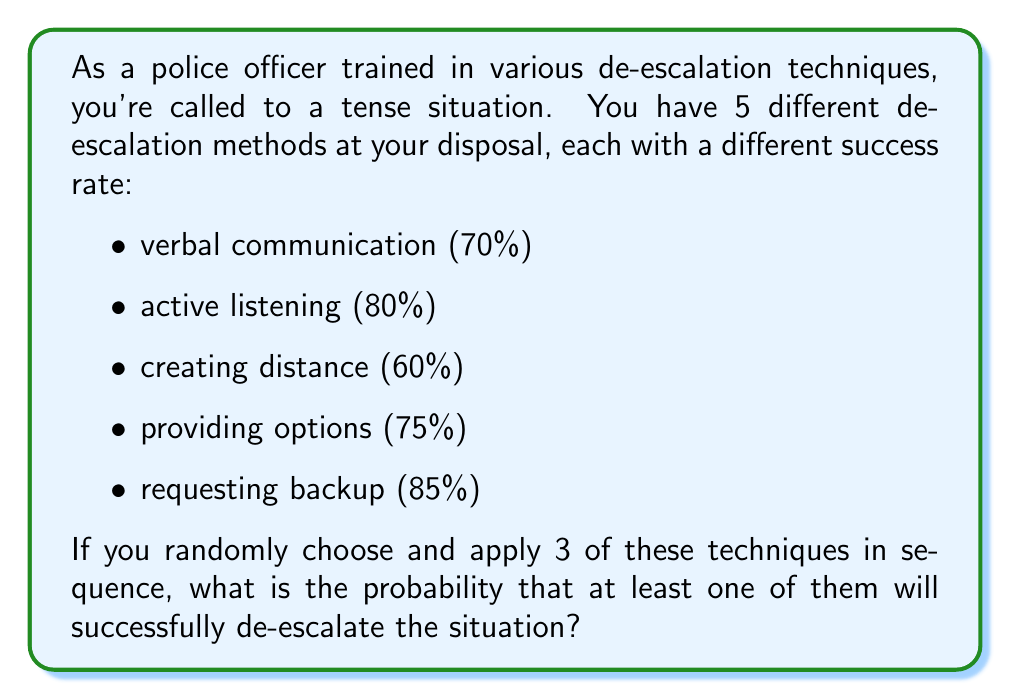Could you help me with this problem? Let's approach this step-by-step:

1) First, we need to calculate the probability of failure for each technique:
   Verbal communication: $1 - 0.70 = 0.30$
   Active listening: $1 - 0.80 = 0.20$
   Creating distance: $1 - 0.60 = 0.40$
   Providing options: $1 - 0.75 = 0.25$
   Requesting backup: $1 - 0.85 = 0.15$

2) Now, we need to calculate the probability of choosing any 3 techniques out of 5. This is a combination problem:

   $$\binom{5}{3} = \frac{5!}{3!(5-3)!} = \frac{5 \cdot 4 \cdot 3}{3 \cdot 2 \cdot 1} = 10$$

   There are 10 possible combinations of 3 techniques.

3) For each combination, we need to calculate the probability that all 3 techniques fail. Then, we'll subtract this from 1 to get the probability of at least one success.

4) Let's calculate the probability for each combination:

   $P(\text{all fail}) = P(\text{fail}_1) \cdot P(\text{fail}_2) \cdot P(\text{fail}_3)$

   For example, for verbal communication, active listening, and creating distance:
   $0.30 \cdot 0.20 \cdot 0.40 = 0.024$

5) Doing this for all 10 combinations and summing:

   $$(0.30 \cdot 0.20 \cdot 0.40) + (0.30 \cdot 0.20 \cdot 0.25) + ... + (0.40 \cdot 0.25 \cdot 0.15) = 0.05175$$

6) This is the probability that all 3 chosen techniques fail. The probability that at least one succeeds is:

   $$1 - 0.05175 = 0.94825$$

Therefore, the probability of successful de-escalation is approximately 0.94825 or 94.825%.
Answer: 0.94825 or 94.825% 